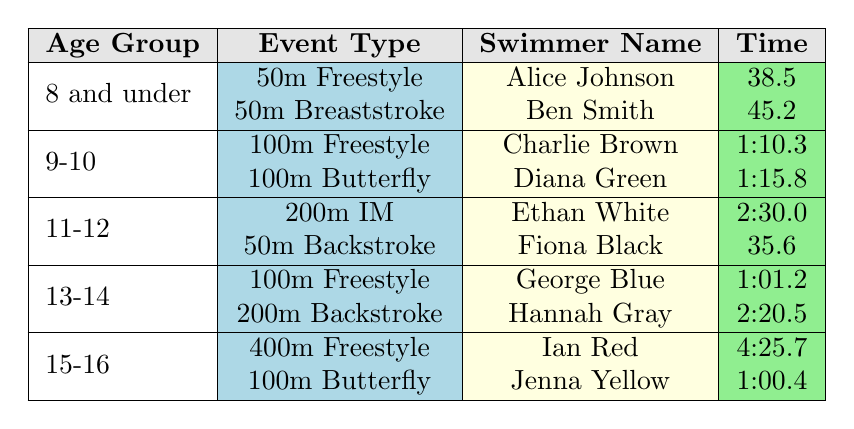What swimmer had the fastest time in the 50m Freestyle event? From the table, the only swimmer listed under the 50m Freestyle event is Alice Johnson, who has a time of 38.5 seconds. Thus, she had the fastest time for this specific event.
Answer: Alice Johnson Which age group had swimmers competing in the 200m event? By examining the table, I see that the 200m event was only represented in the 11-12 age group with Ethan White in the 200m IM and Hannah Gray in the 200m Backstroke. Therefore, the age group is 11-12.
Answer: 11-12 Is there any swimmer in the 13-14 age group who participated in the 100m Butterfly event? Looking at the table, it shows that Jenna Yellow participated in the 100m Butterfly, but she belongs to the 15-16 age group, not 13-14. Therefore, the answer is no.
Answer: No What is the average time of the swimmers in the 15-16 age group? There are two swimmers in the 15-16 age group: Ian Red with a time of 4:25.7 (or 265.7 seconds) and Jenna Yellow with a time of 1:00.4 (or 60.4 seconds). To find the average, I sum the times (265.7 + 60.4 = 326.1 seconds) and then divide by 2 (326.1 / 2 = 163.05 seconds). The average time is approximately 2:43.1 when converted back to minutes and seconds.
Answer: 2:43.1 Which event had the swimmer with the longest recorded time? The longest time recorded in the table is Ian Red's 4:25.7 in the 400m Freestyle event. Therefore, the event is 400m Freestyle.
Answer: 400m Freestyle How many swimmers participated in the 11-12 age group? The table shows that there are two swimmers in the 11-12 age group: Ethan White and Fiona Black. Thus, the total number of swimmers in this age group is 2.
Answer: 2 Is the time of Charlie Brown faster than that of Jenna Yellow? By comparing the times, Charlie Brown has a time of 1:10.3 (or 70.3 seconds), while Jenna Yellow has a time of 1:00.4 (or 60.4 seconds). Since 60.4 seconds is less than 70.3 seconds, Charlie Brown is not faster than Jenna Yellow.
Answer: No What is the combined total time of all swimmers in the 9-10 age group? The 9-10 age group has two swimmers: Charlie Brown with a time of 1:10.3 (70.3 seconds) and Diana Green with a time of 1:15.8 (75.8 seconds). Adding these gives (70.3 + 75.8 = 146.1 seconds). Converting back to minutes and seconds, the combined total time is approximately 2:26.1.
Answer: 2:26.1 